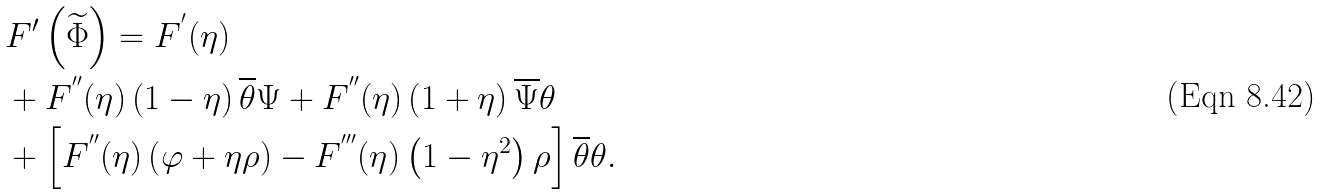<formula> <loc_0><loc_0><loc_500><loc_500>& F ^ { \prime } \left ( \widetilde { \Phi } \right ) = F ^ { ^ { \prime } } ( \eta ) \\ & + F ^ { ^ { \prime \prime } } ( \eta ) \left ( 1 - \eta \right ) \overline { \theta } \Psi + F ^ { ^ { \prime \prime } } ( \eta ) \left ( 1 + \eta \right ) \overline { \Psi } \theta \\ & + \left [ F ^ { ^ { \prime \prime } } ( \eta ) \left ( \varphi + \eta \rho \right ) - F ^ { ^ { \prime \prime \prime } } ( \eta ) \left ( 1 - \eta ^ { 2 } \right ) \rho \right ] \overline { \theta } \theta .</formula> 